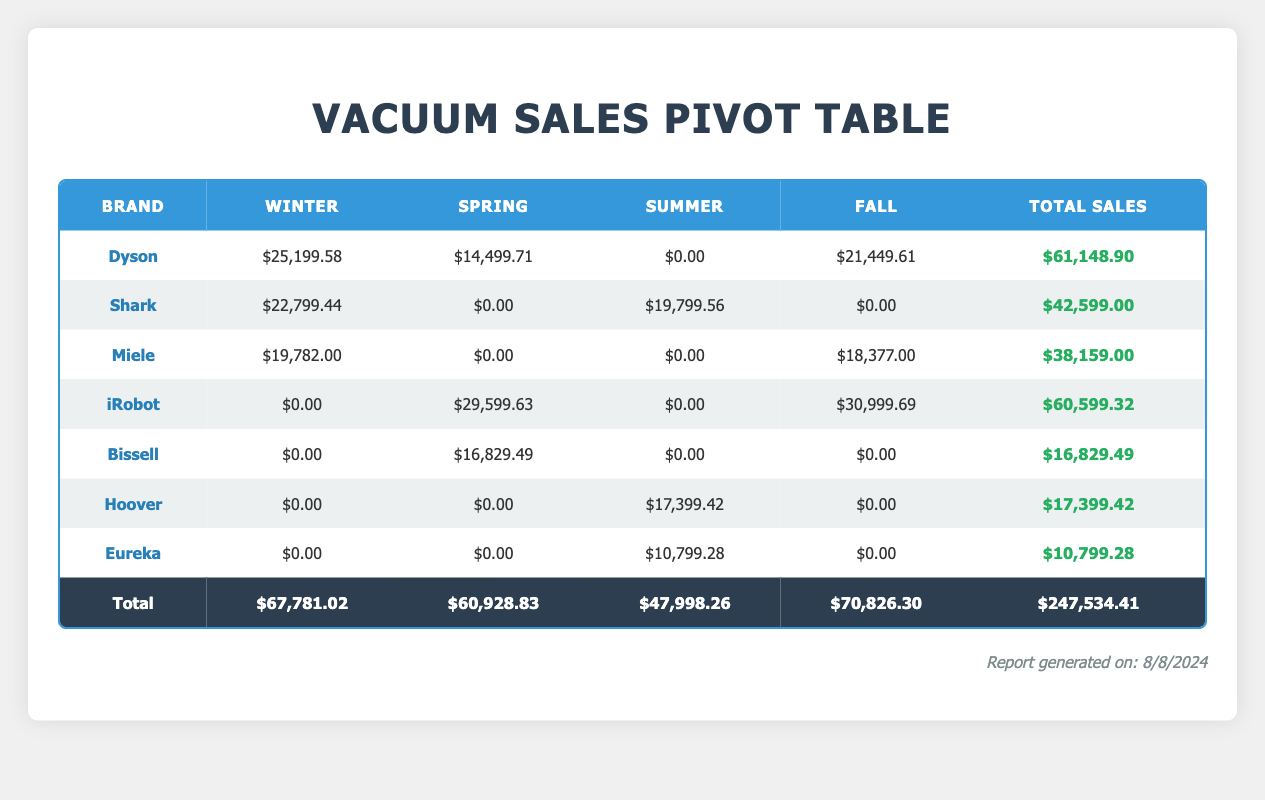What is the total sales for Dyson vacuums? From the table, we can see that the total sales for Dyson in all seasons is $61,148.90, which is provided in the last column under 'Total Sales'.
Answer: $61,148.90 Which brand sold more units during the Winter season, Dyson or Shark? Dyson sold 42 units and Shark sold 65 units during Winter. Since 65 is greater than 42, Shark sold more units in Winter.
Answer: Shark What is the total sales amount for Spring vacuums? By looking at the Spring column, we can sum the total sales for each brand: Bissell ($16,829.49) + Dyson ($14,499.71) + iRobot ($29,599.63) = $60,928.83. This value is directly from the table.
Answer: $60,928.83 Did Miele sell any units during the Summer season? The table shows that Miele has no sales listed for the Summer season as its corresponding cell under Summer is $0.00.
Answer: No What is the difference between total sales of Shark in Summer and Winter? Shark's total sales in Summer is $19,799.56 and in Winter is $22,799.44. The difference is $22,799.44 - $19,799.56 = $3,000.88, calculated from the values in their respective columns.
Answer: $3,000.88 Which season generated the highest total sales overall? Looking at the total sales for each season: Winter ($67,781.02), Spring ($60,928.83), Summer ($47,998.26), and Fall ($70,826.30), we see that Fall has the highest total sales of $70,826.30.
Answer: Fall What percentage of total sales does Eureka represent? Total sales is $247,534.41. Eureka's sales is $10,799.28. The percentage is calculated as ($10,799.28 / $247,534.41) * 100 = approximately 4.36%. This is derived from using the total sales value and Eureka's sales value from the table.
Answer: 4.36% Is it true that iRobot generated more sales in Spring than in Fall? iRobot had total sales of $29,599.63 in Spring and $30,999.69 in Fall. Since $30,999.69 is greater than $29,599.63, the statement is false.
Answer: False 